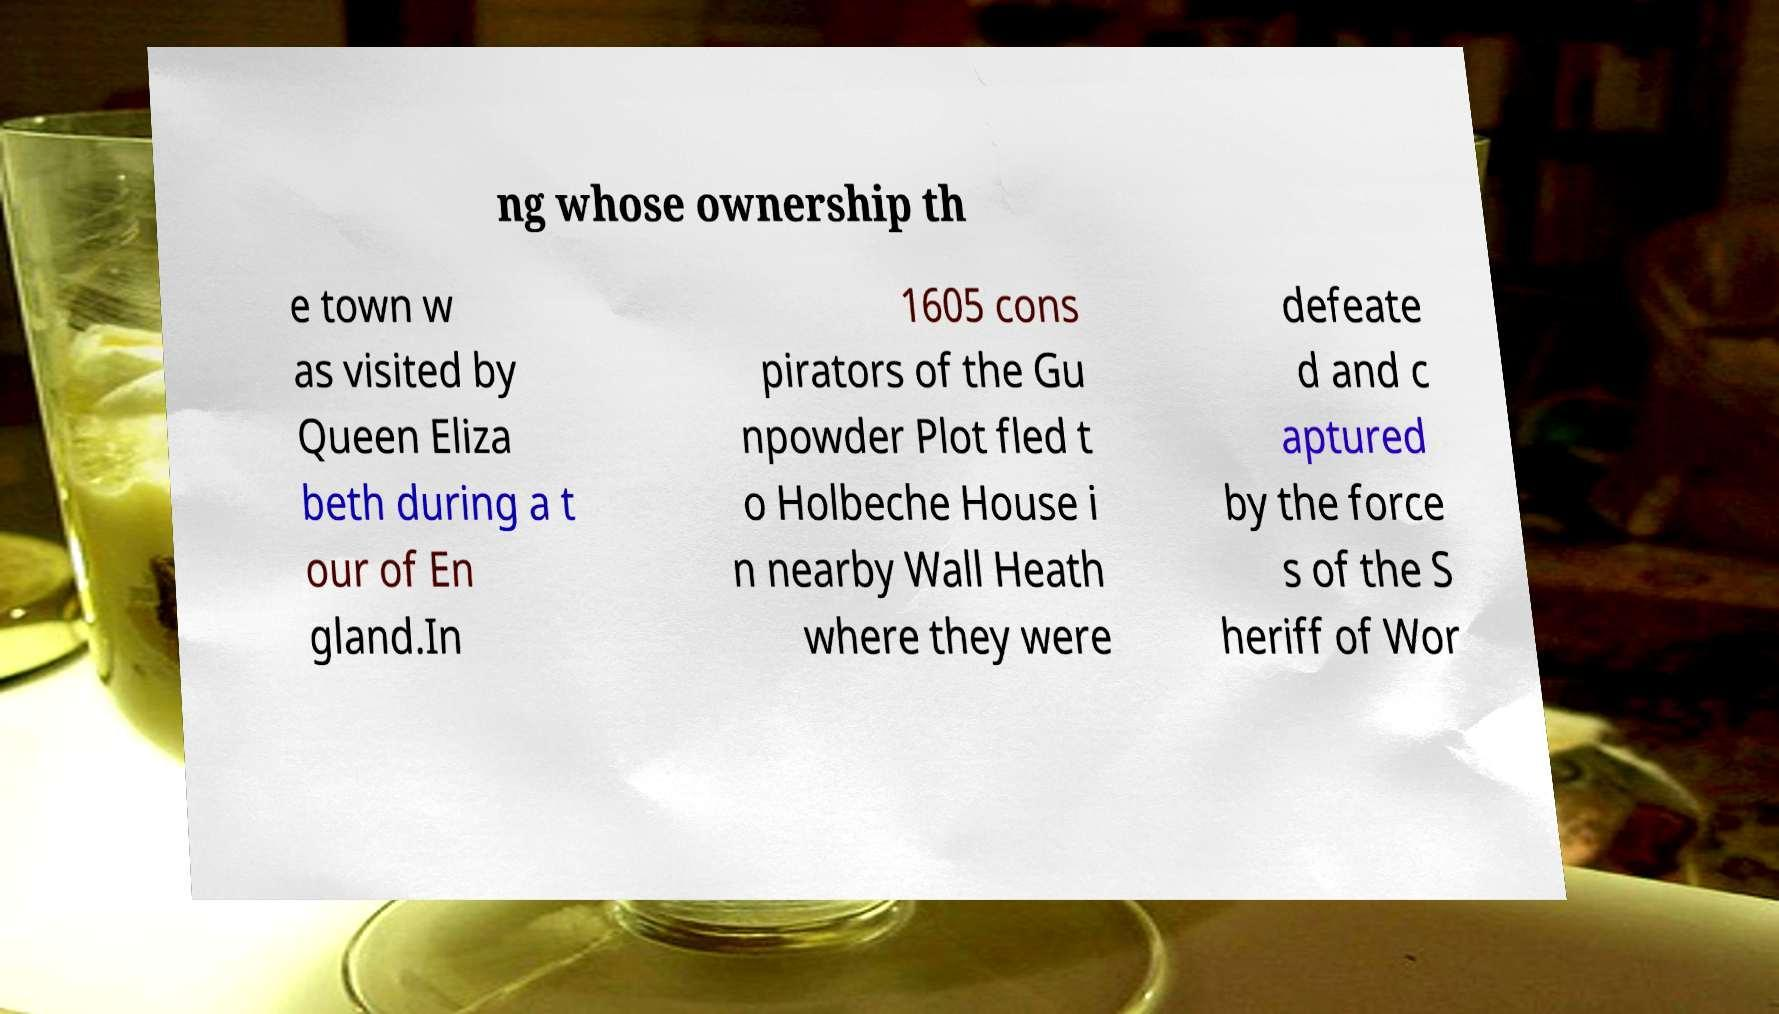Please read and relay the text visible in this image. What does it say? ng whose ownership th e town w as visited by Queen Eliza beth during a t our of En gland.In 1605 cons pirators of the Gu npowder Plot fled t o Holbeche House i n nearby Wall Heath where they were defeate d and c aptured by the force s of the S heriff of Wor 